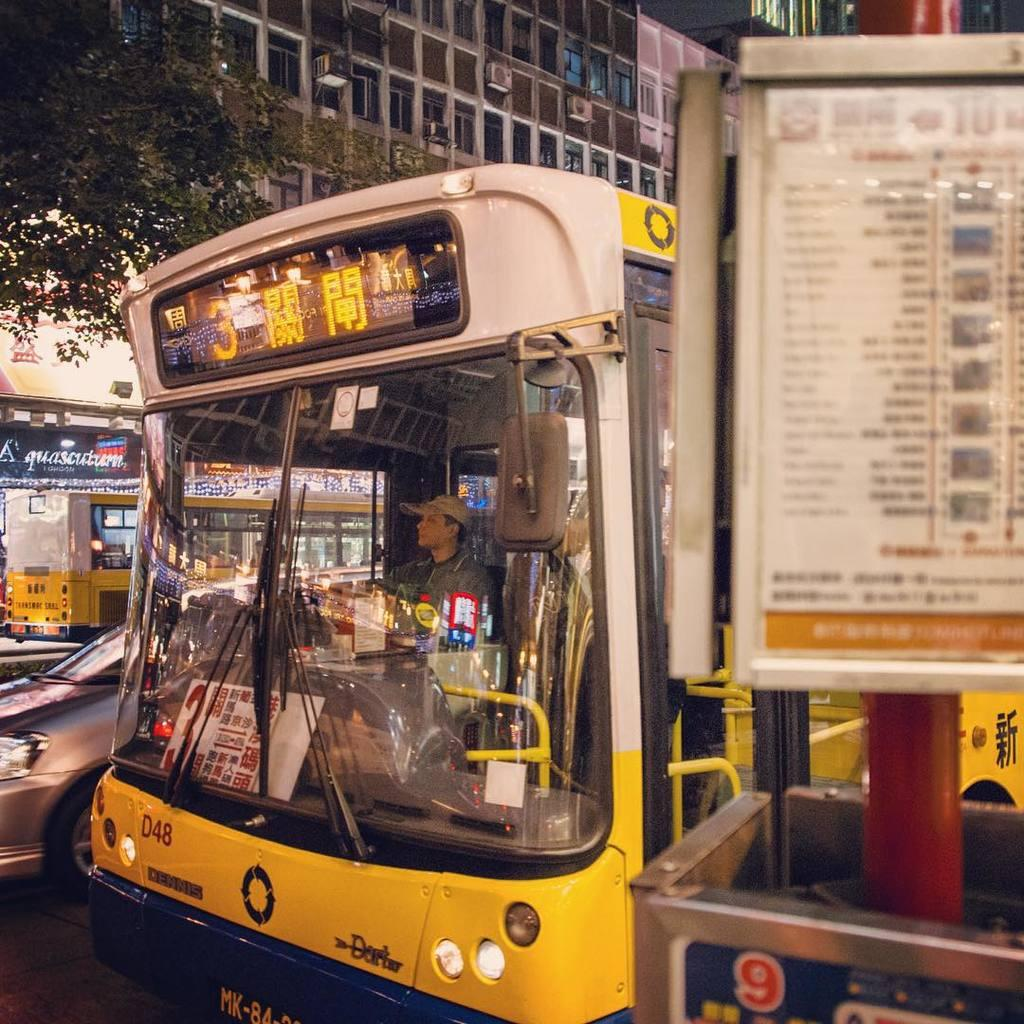<image>
Present a compact description of the photo's key features. A public bus with the number 3 and foreign characters as its destination. 